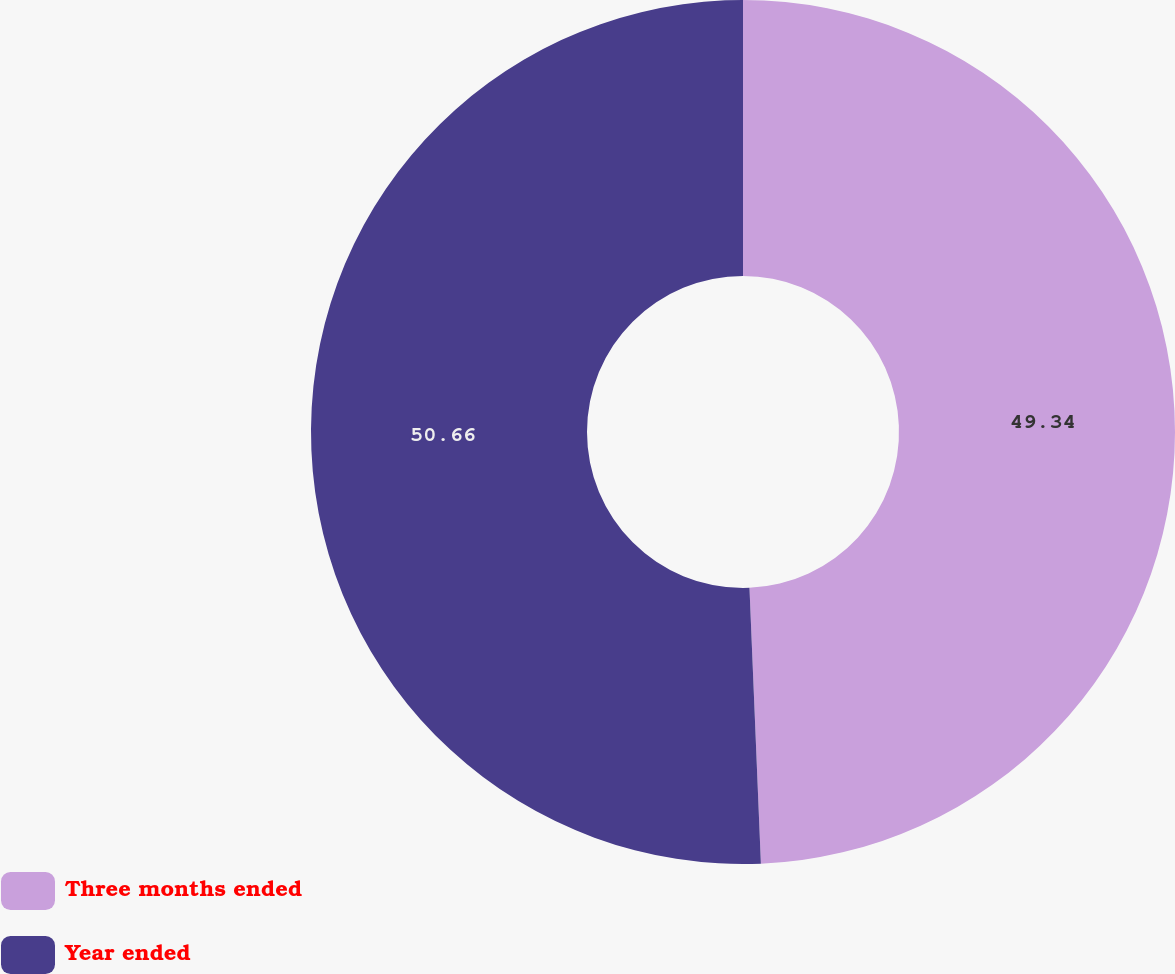Convert chart to OTSL. <chart><loc_0><loc_0><loc_500><loc_500><pie_chart><fcel>Three months ended<fcel>Year ended<nl><fcel>49.34%<fcel>50.66%<nl></chart> 